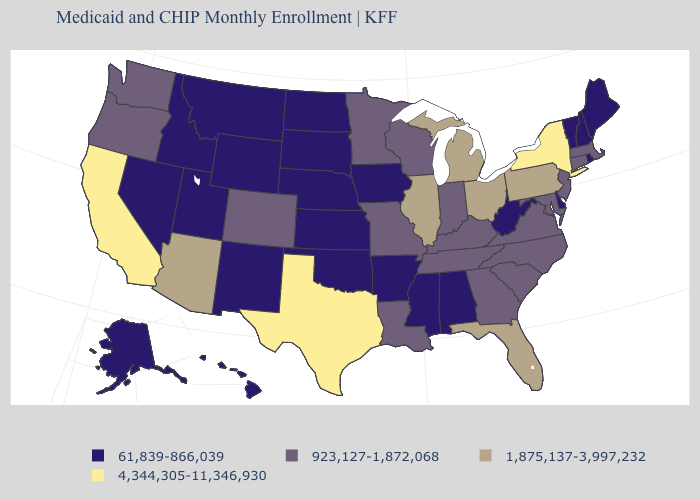What is the value of Utah?
Give a very brief answer. 61,839-866,039. Does the first symbol in the legend represent the smallest category?
Write a very short answer. Yes. What is the value of Hawaii?
Be succinct. 61,839-866,039. Among the states that border Colorado , which have the highest value?
Keep it brief. Arizona. Name the states that have a value in the range 4,344,305-11,346,930?
Keep it brief. California, New York, Texas. What is the value of Oklahoma?
Be succinct. 61,839-866,039. What is the value of Oregon?
Give a very brief answer. 923,127-1,872,068. Name the states that have a value in the range 1,875,137-3,997,232?
Answer briefly. Arizona, Florida, Illinois, Michigan, Ohio, Pennsylvania. What is the highest value in states that border Virginia?
Quick response, please. 923,127-1,872,068. How many symbols are there in the legend?
Write a very short answer. 4. What is the value of Ohio?
Give a very brief answer. 1,875,137-3,997,232. What is the lowest value in states that border Utah?
Short answer required. 61,839-866,039. How many symbols are there in the legend?
Write a very short answer. 4. What is the value of Wisconsin?
Give a very brief answer. 923,127-1,872,068. What is the value of Arkansas?
Be succinct. 61,839-866,039. 